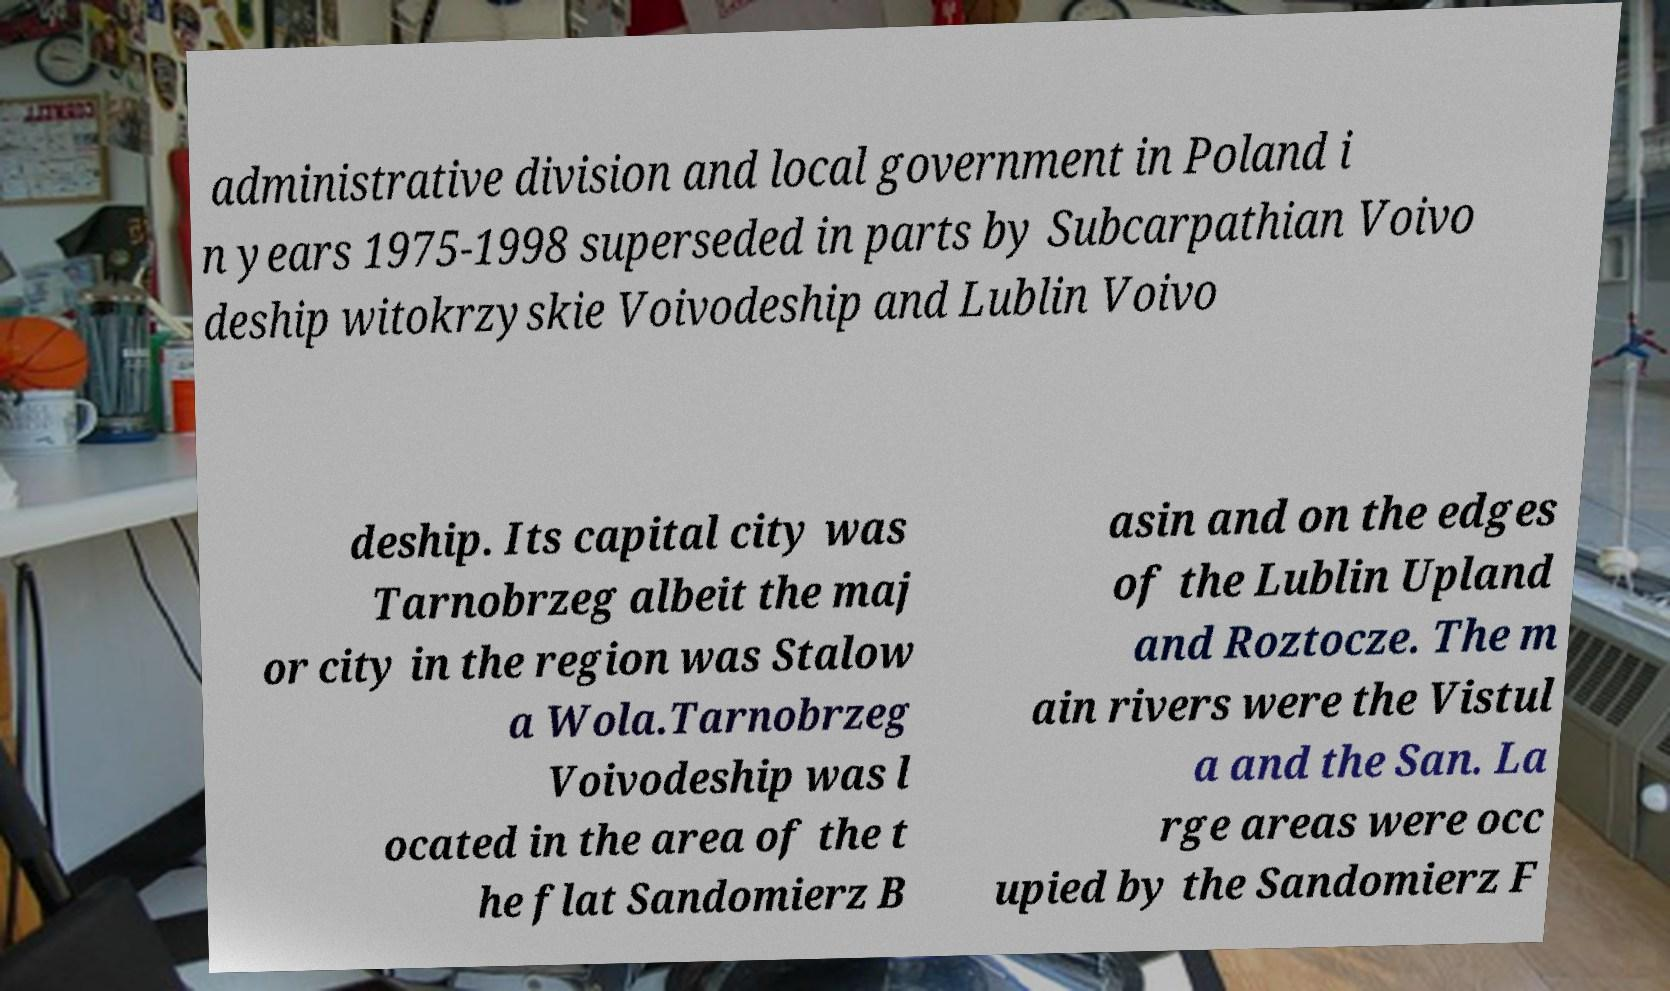For documentation purposes, I need the text within this image transcribed. Could you provide that? administrative division and local government in Poland i n years 1975-1998 superseded in parts by Subcarpathian Voivo deship witokrzyskie Voivodeship and Lublin Voivo deship. Its capital city was Tarnobrzeg albeit the maj or city in the region was Stalow a Wola.Tarnobrzeg Voivodeship was l ocated in the area of the t he flat Sandomierz B asin and on the edges of the Lublin Upland and Roztocze. The m ain rivers were the Vistul a and the San. La rge areas were occ upied by the Sandomierz F 